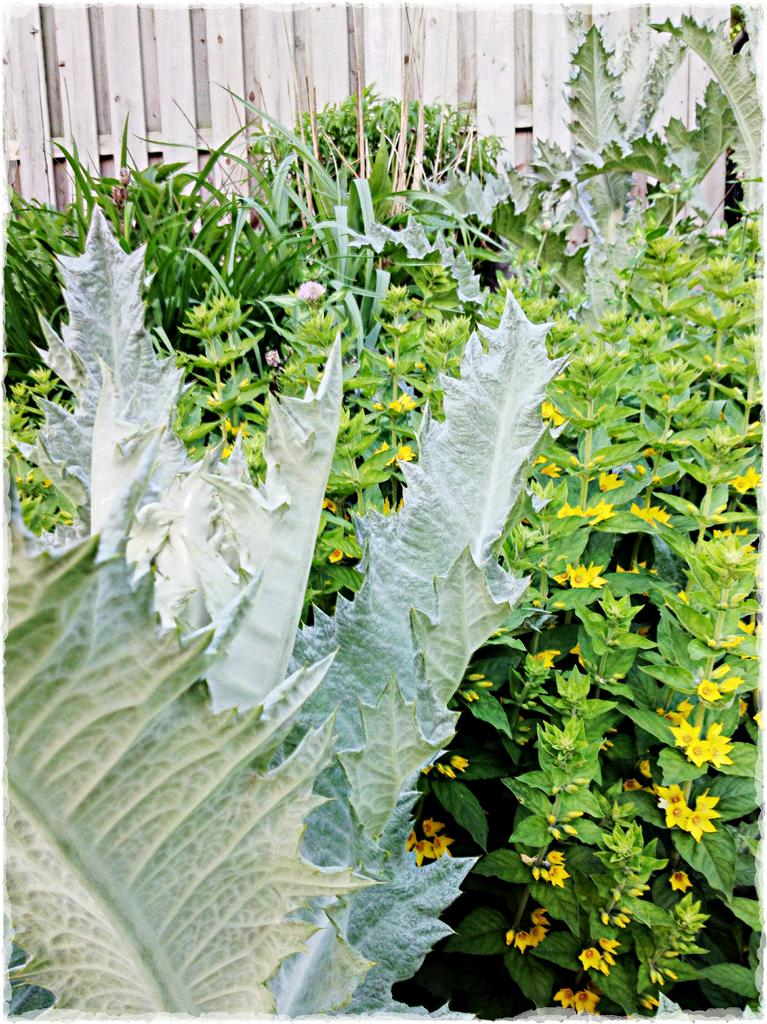What type of vegetation can be seen in the image? There are leaves, plants, and flowers in the image. What is the primary feature in the background of the image? There is a fence in the background of the image. What is the caption of the image? There is no caption present in the image. How many ducks are visible in the image? There are no ducks present in the image. 